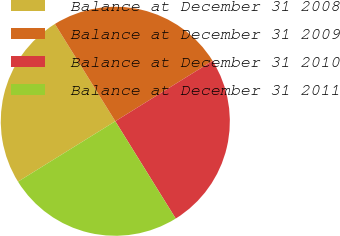Convert chart to OTSL. <chart><loc_0><loc_0><loc_500><loc_500><pie_chart><fcel>Balance at December 31 2008<fcel>Balance at December 31 2009<fcel>Balance at December 31 2010<fcel>Balance at December 31 2011<nl><fcel>25.0%<fcel>25.0%<fcel>25.0%<fcel>25.0%<nl></chart> 